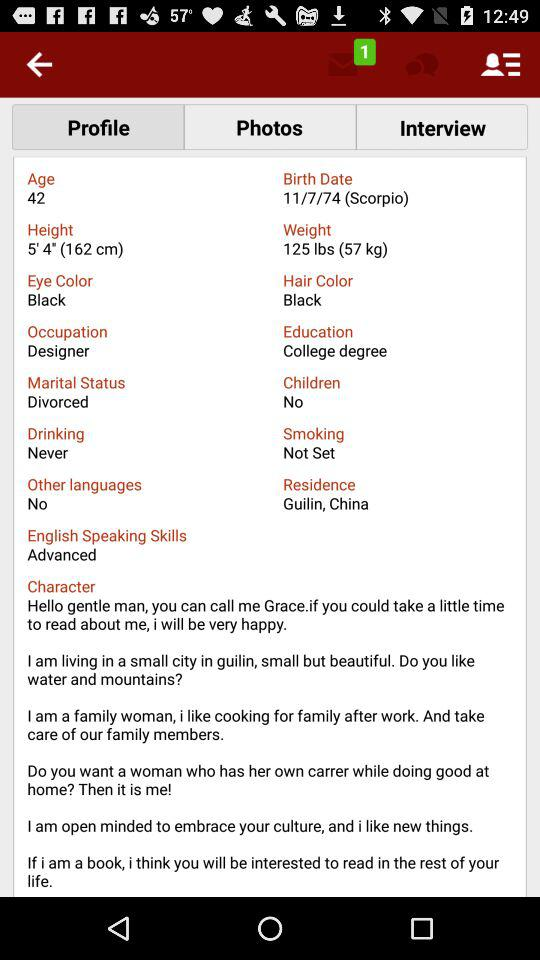What is Grace's height in meters?
Answer the question using a single word or phrase. 1.62 